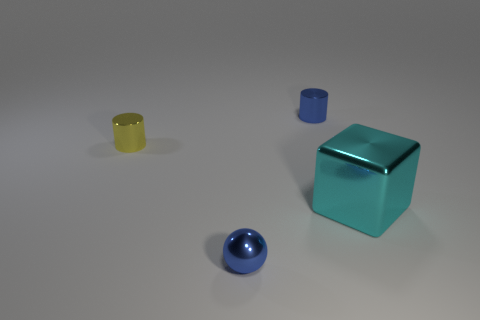Are there any small metallic objects of the same color as the small sphere?
Provide a succinct answer. Yes. There is a tiny cylinder that is the same color as the ball; what is its material?
Keep it short and to the point. Metal. What is the size of the thing that is the same color as the ball?
Your response must be concise. Small. How many other things are the same shape as the tiny yellow object?
Provide a succinct answer. 1. Is the number of blue metal objects that are in front of the tiny yellow metal cylinder less than the number of metallic things left of the big metallic block?
Offer a terse response. Yes. What is the shape of the small yellow thing that is made of the same material as the cyan thing?
Provide a short and direct response. Cylinder. Is there anything else that is the same color as the small metallic sphere?
Provide a succinct answer. Yes. The object that is on the left side of the tiny thing in front of the small yellow shiny cylinder is what color?
Provide a short and direct response. Yellow. What number of other yellow things have the same size as the yellow object?
Your answer should be very brief. 0. The thing that is to the left of the blue cylinder and behind the small blue metal sphere is made of what material?
Your response must be concise. Metal. 